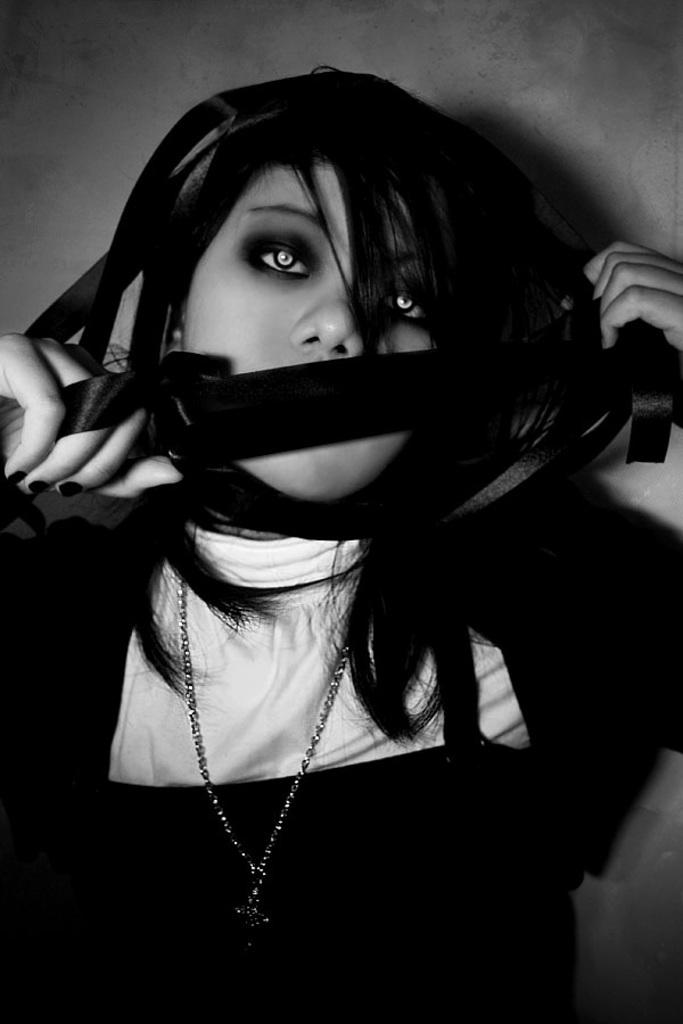Who is present in the image? There is a woman in the image. What is the woman holding in the image? The woman is holding a cloth. What can be seen in the background of the image? There is a wall visible in the background of the image. What is the woman doing to the sun in the image? There is no sun present in the image, so the woman cannot be doing anything to it. 